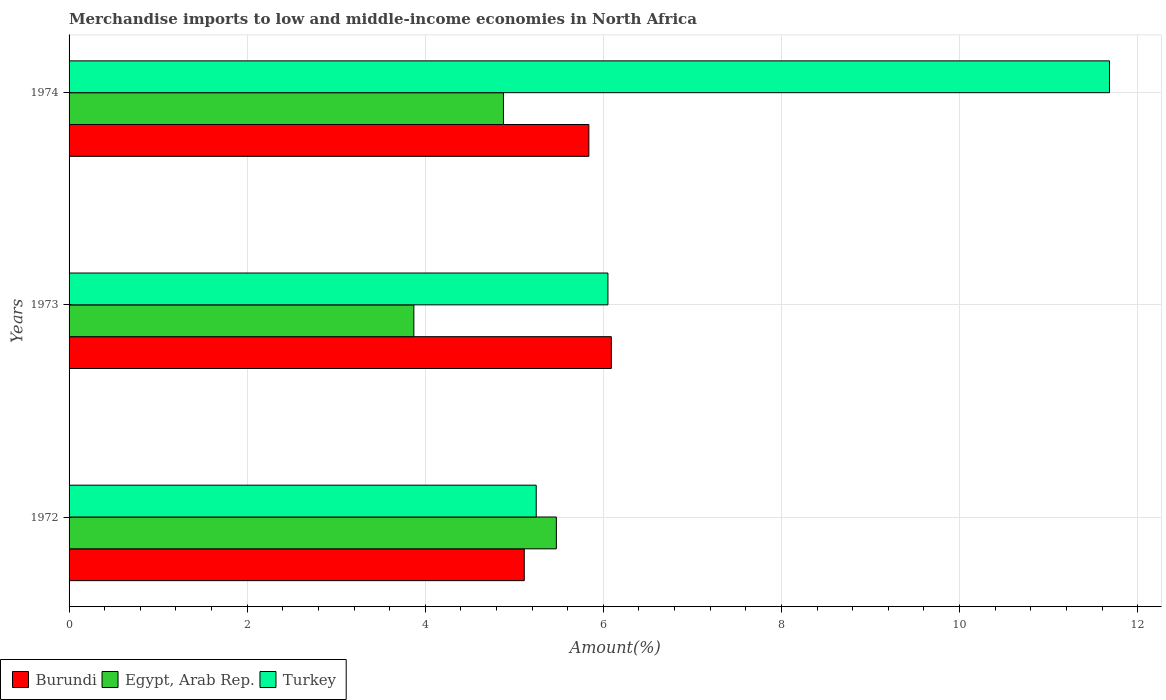How many groups of bars are there?
Provide a succinct answer. 3. Are the number of bars per tick equal to the number of legend labels?
Keep it short and to the point. Yes. How many bars are there on the 2nd tick from the bottom?
Ensure brevity in your answer.  3. What is the percentage of amount earned from merchandise imports in Burundi in 1972?
Provide a succinct answer. 5.11. Across all years, what is the maximum percentage of amount earned from merchandise imports in Burundi?
Ensure brevity in your answer.  6.09. Across all years, what is the minimum percentage of amount earned from merchandise imports in Turkey?
Your response must be concise. 5.25. What is the total percentage of amount earned from merchandise imports in Egypt, Arab Rep. in the graph?
Offer a terse response. 14.22. What is the difference between the percentage of amount earned from merchandise imports in Turkey in 1973 and that in 1974?
Ensure brevity in your answer.  -5.63. What is the difference between the percentage of amount earned from merchandise imports in Turkey in 1973 and the percentage of amount earned from merchandise imports in Burundi in 1972?
Ensure brevity in your answer.  0.94. What is the average percentage of amount earned from merchandise imports in Turkey per year?
Offer a terse response. 7.66. In the year 1974, what is the difference between the percentage of amount earned from merchandise imports in Turkey and percentage of amount earned from merchandise imports in Burundi?
Keep it short and to the point. 5.85. What is the ratio of the percentage of amount earned from merchandise imports in Egypt, Arab Rep. in 1972 to that in 1973?
Your response must be concise. 1.41. Is the percentage of amount earned from merchandise imports in Egypt, Arab Rep. in 1972 less than that in 1974?
Ensure brevity in your answer.  No. What is the difference between the highest and the second highest percentage of amount earned from merchandise imports in Turkey?
Your answer should be compact. 5.63. What is the difference between the highest and the lowest percentage of amount earned from merchandise imports in Turkey?
Your response must be concise. 6.44. Is the sum of the percentage of amount earned from merchandise imports in Burundi in 1973 and 1974 greater than the maximum percentage of amount earned from merchandise imports in Egypt, Arab Rep. across all years?
Keep it short and to the point. Yes. What does the 1st bar from the top in 1974 represents?
Your answer should be compact. Turkey. How many bars are there?
Offer a very short reply. 9. Are all the bars in the graph horizontal?
Offer a very short reply. Yes. How many years are there in the graph?
Your answer should be compact. 3. What is the difference between two consecutive major ticks on the X-axis?
Your response must be concise. 2. Are the values on the major ticks of X-axis written in scientific E-notation?
Give a very brief answer. No. How many legend labels are there?
Your response must be concise. 3. How are the legend labels stacked?
Your answer should be compact. Horizontal. What is the title of the graph?
Your response must be concise. Merchandise imports to low and middle-income economies in North Africa. Does "Sub-Saharan Africa (developing only)" appear as one of the legend labels in the graph?
Make the answer very short. No. What is the label or title of the X-axis?
Give a very brief answer. Amount(%). What is the Amount(%) in Burundi in 1972?
Make the answer very short. 5.11. What is the Amount(%) of Egypt, Arab Rep. in 1972?
Ensure brevity in your answer.  5.47. What is the Amount(%) in Turkey in 1972?
Offer a very short reply. 5.25. What is the Amount(%) of Burundi in 1973?
Provide a short and direct response. 6.09. What is the Amount(%) of Egypt, Arab Rep. in 1973?
Your answer should be very brief. 3.87. What is the Amount(%) of Turkey in 1973?
Make the answer very short. 6.05. What is the Amount(%) in Burundi in 1974?
Provide a succinct answer. 5.84. What is the Amount(%) of Egypt, Arab Rep. in 1974?
Offer a terse response. 4.88. What is the Amount(%) in Turkey in 1974?
Provide a succinct answer. 11.68. Across all years, what is the maximum Amount(%) of Burundi?
Offer a very short reply. 6.09. Across all years, what is the maximum Amount(%) of Egypt, Arab Rep.?
Give a very brief answer. 5.47. Across all years, what is the maximum Amount(%) in Turkey?
Ensure brevity in your answer.  11.68. Across all years, what is the minimum Amount(%) of Burundi?
Your answer should be very brief. 5.11. Across all years, what is the minimum Amount(%) in Egypt, Arab Rep.?
Offer a very short reply. 3.87. Across all years, what is the minimum Amount(%) of Turkey?
Offer a very short reply. 5.25. What is the total Amount(%) in Burundi in the graph?
Provide a short and direct response. 17.04. What is the total Amount(%) in Egypt, Arab Rep. in the graph?
Your answer should be compact. 14.22. What is the total Amount(%) in Turkey in the graph?
Your answer should be compact. 22.98. What is the difference between the Amount(%) of Burundi in 1972 and that in 1973?
Your answer should be compact. -0.98. What is the difference between the Amount(%) of Egypt, Arab Rep. in 1972 and that in 1973?
Offer a very short reply. 1.6. What is the difference between the Amount(%) in Turkey in 1972 and that in 1973?
Ensure brevity in your answer.  -0.81. What is the difference between the Amount(%) in Burundi in 1972 and that in 1974?
Your answer should be compact. -0.73. What is the difference between the Amount(%) in Egypt, Arab Rep. in 1972 and that in 1974?
Offer a very short reply. 0.59. What is the difference between the Amount(%) of Turkey in 1972 and that in 1974?
Keep it short and to the point. -6.44. What is the difference between the Amount(%) of Burundi in 1973 and that in 1974?
Your response must be concise. 0.25. What is the difference between the Amount(%) in Egypt, Arab Rep. in 1973 and that in 1974?
Ensure brevity in your answer.  -1.01. What is the difference between the Amount(%) in Turkey in 1973 and that in 1974?
Keep it short and to the point. -5.63. What is the difference between the Amount(%) of Burundi in 1972 and the Amount(%) of Egypt, Arab Rep. in 1973?
Offer a very short reply. 1.24. What is the difference between the Amount(%) of Burundi in 1972 and the Amount(%) of Turkey in 1973?
Give a very brief answer. -0.94. What is the difference between the Amount(%) of Egypt, Arab Rep. in 1972 and the Amount(%) of Turkey in 1973?
Keep it short and to the point. -0.58. What is the difference between the Amount(%) in Burundi in 1972 and the Amount(%) in Egypt, Arab Rep. in 1974?
Your response must be concise. 0.23. What is the difference between the Amount(%) in Burundi in 1972 and the Amount(%) in Turkey in 1974?
Keep it short and to the point. -6.57. What is the difference between the Amount(%) of Egypt, Arab Rep. in 1972 and the Amount(%) of Turkey in 1974?
Offer a very short reply. -6.21. What is the difference between the Amount(%) of Burundi in 1973 and the Amount(%) of Egypt, Arab Rep. in 1974?
Your response must be concise. 1.21. What is the difference between the Amount(%) of Burundi in 1973 and the Amount(%) of Turkey in 1974?
Make the answer very short. -5.59. What is the difference between the Amount(%) of Egypt, Arab Rep. in 1973 and the Amount(%) of Turkey in 1974?
Offer a terse response. -7.81. What is the average Amount(%) of Burundi per year?
Ensure brevity in your answer.  5.68. What is the average Amount(%) in Egypt, Arab Rep. per year?
Provide a short and direct response. 4.74. What is the average Amount(%) of Turkey per year?
Provide a succinct answer. 7.66. In the year 1972, what is the difference between the Amount(%) of Burundi and Amount(%) of Egypt, Arab Rep.?
Your answer should be compact. -0.36. In the year 1972, what is the difference between the Amount(%) of Burundi and Amount(%) of Turkey?
Ensure brevity in your answer.  -0.13. In the year 1972, what is the difference between the Amount(%) in Egypt, Arab Rep. and Amount(%) in Turkey?
Ensure brevity in your answer.  0.23. In the year 1973, what is the difference between the Amount(%) in Burundi and Amount(%) in Egypt, Arab Rep.?
Provide a short and direct response. 2.22. In the year 1973, what is the difference between the Amount(%) in Burundi and Amount(%) in Turkey?
Provide a short and direct response. 0.04. In the year 1973, what is the difference between the Amount(%) in Egypt, Arab Rep. and Amount(%) in Turkey?
Provide a short and direct response. -2.18. In the year 1974, what is the difference between the Amount(%) in Burundi and Amount(%) in Egypt, Arab Rep.?
Provide a short and direct response. 0.96. In the year 1974, what is the difference between the Amount(%) in Burundi and Amount(%) in Turkey?
Keep it short and to the point. -5.85. In the year 1974, what is the difference between the Amount(%) of Egypt, Arab Rep. and Amount(%) of Turkey?
Your response must be concise. -6.81. What is the ratio of the Amount(%) in Burundi in 1972 to that in 1973?
Your answer should be very brief. 0.84. What is the ratio of the Amount(%) in Egypt, Arab Rep. in 1972 to that in 1973?
Offer a terse response. 1.41. What is the ratio of the Amount(%) in Turkey in 1972 to that in 1973?
Give a very brief answer. 0.87. What is the ratio of the Amount(%) of Burundi in 1972 to that in 1974?
Ensure brevity in your answer.  0.88. What is the ratio of the Amount(%) in Egypt, Arab Rep. in 1972 to that in 1974?
Provide a succinct answer. 1.12. What is the ratio of the Amount(%) of Turkey in 1972 to that in 1974?
Provide a short and direct response. 0.45. What is the ratio of the Amount(%) of Burundi in 1973 to that in 1974?
Give a very brief answer. 1.04. What is the ratio of the Amount(%) of Egypt, Arab Rep. in 1973 to that in 1974?
Give a very brief answer. 0.79. What is the ratio of the Amount(%) in Turkey in 1973 to that in 1974?
Your answer should be compact. 0.52. What is the difference between the highest and the second highest Amount(%) of Burundi?
Make the answer very short. 0.25. What is the difference between the highest and the second highest Amount(%) of Egypt, Arab Rep.?
Ensure brevity in your answer.  0.59. What is the difference between the highest and the second highest Amount(%) in Turkey?
Keep it short and to the point. 5.63. What is the difference between the highest and the lowest Amount(%) of Burundi?
Your response must be concise. 0.98. What is the difference between the highest and the lowest Amount(%) of Egypt, Arab Rep.?
Your response must be concise. 1.6. What is the difference between the highest and the lowest Amount(%) in Turkey?
Keep it short and to the point. 6.44. 